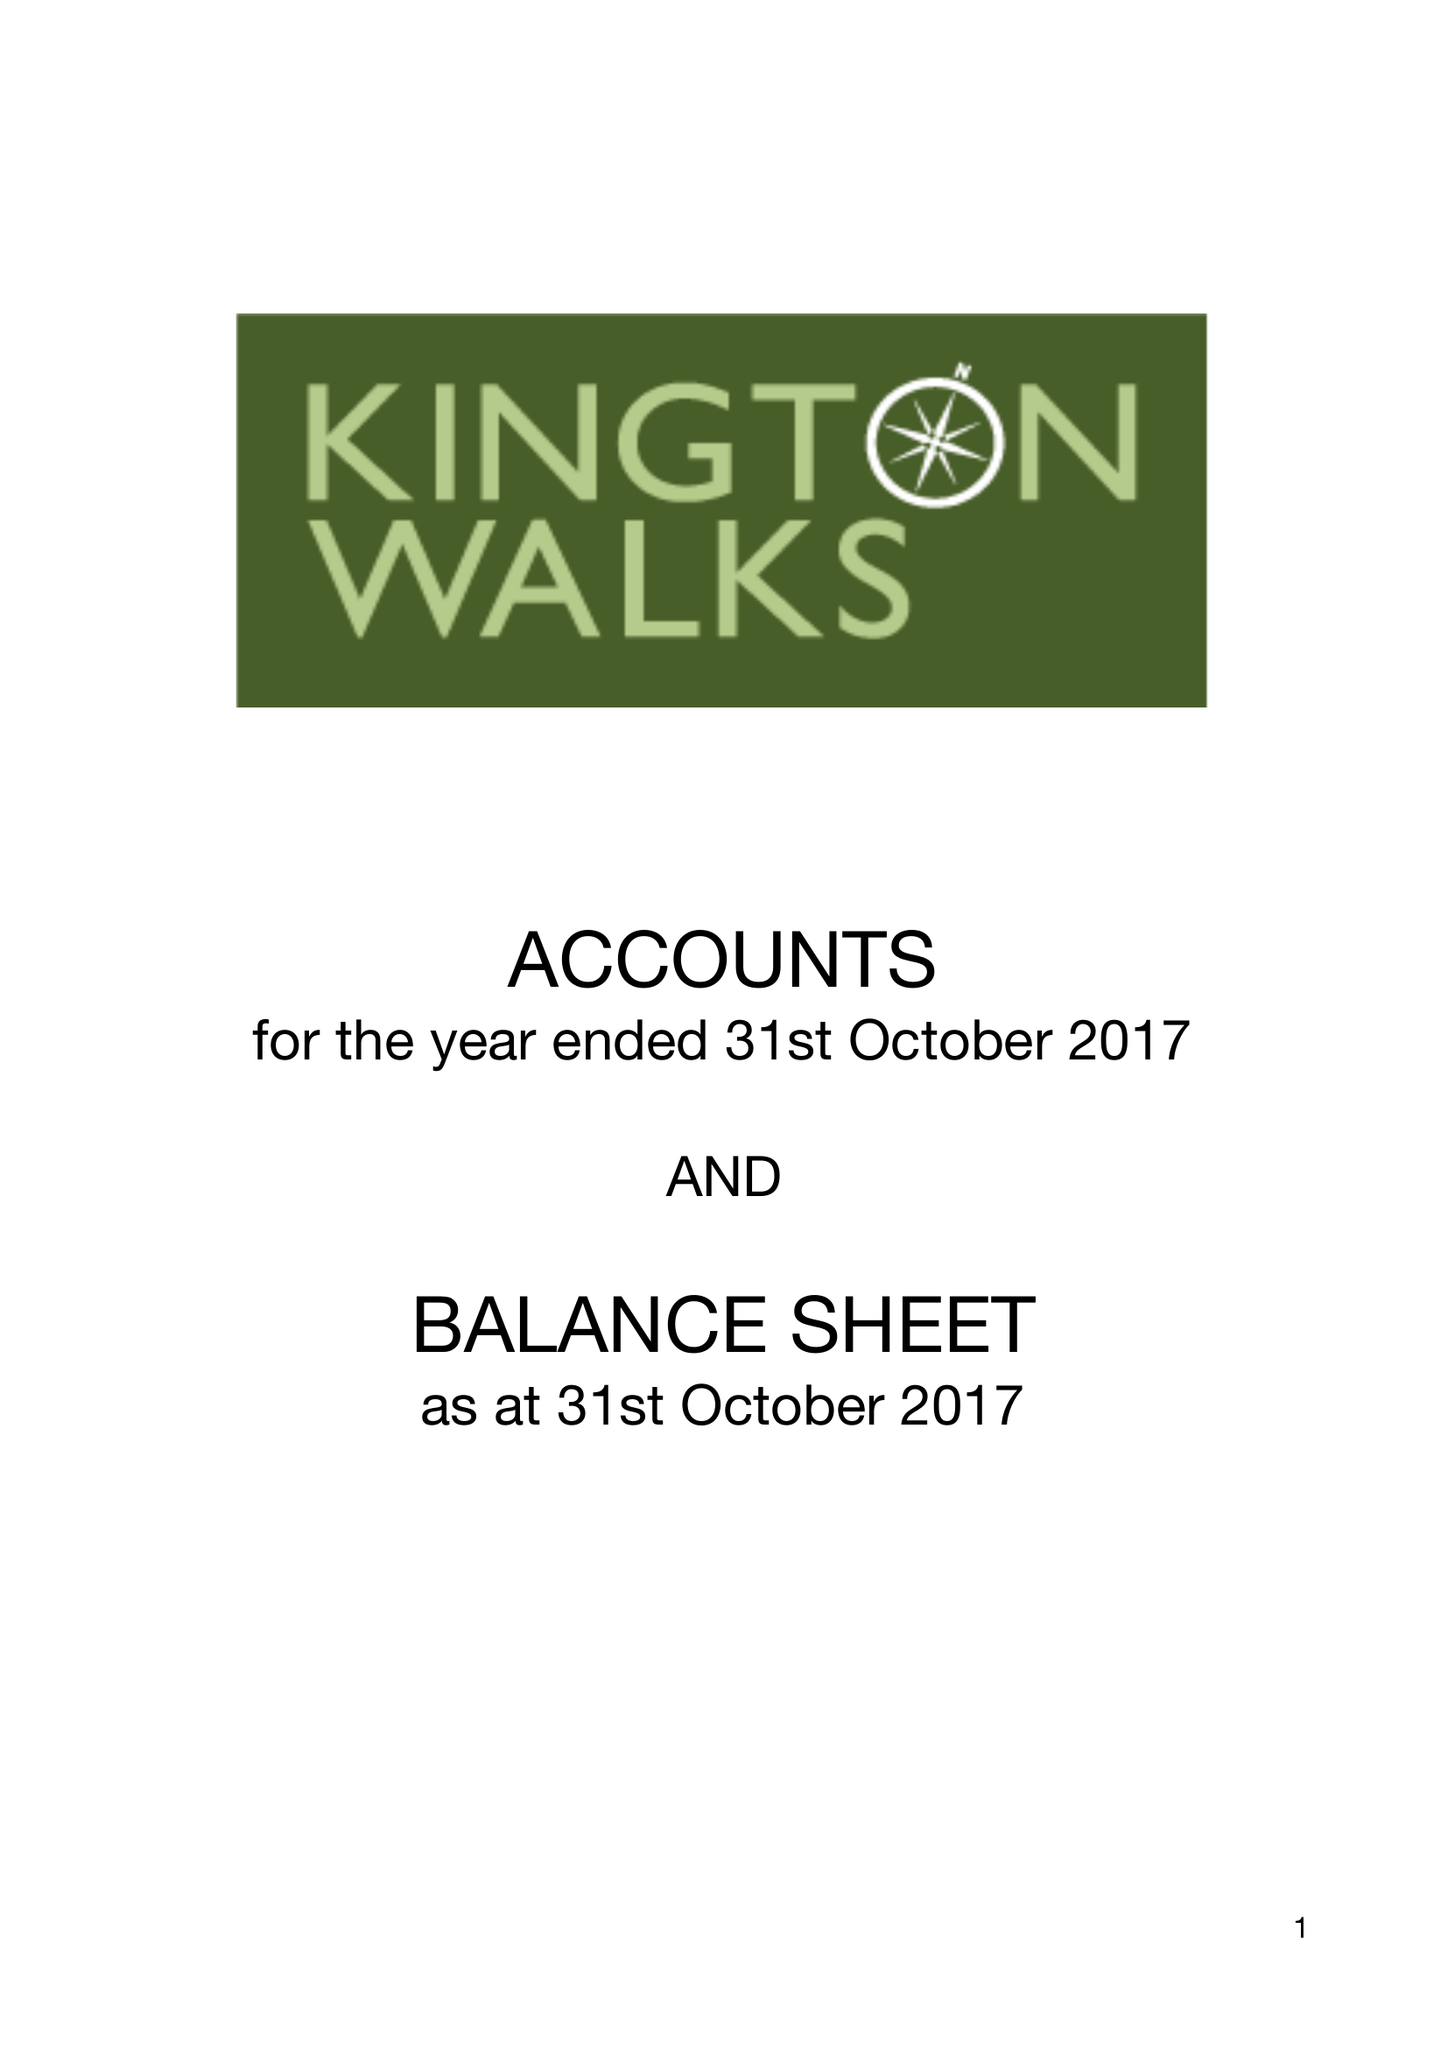What is the value for the report_date?
Answer the question using a single word or phrase. 2017-10-31 